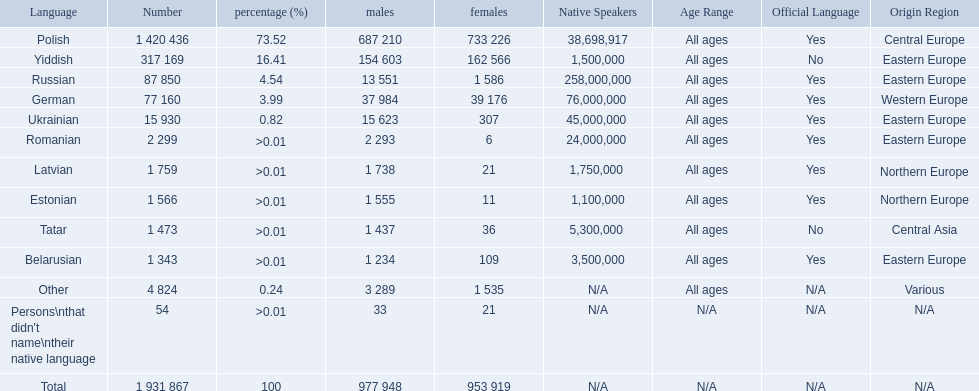What are all of the languages Polish, Yiddish, Russian, German, Ukrainian, Romanian, Latvian, Estonian, Tatar, Belarusian, Other, Persons\nthat didn't name\ntheir native language. What was the percentage of each? 73.52, 16.41, 4.54, 3.99, 0.82, >0.01, >0.01, >0.01, >0.01, >0.01, 0.24, >0.01. Which languages had a >0.01	 percentage? Romanian, Latvian, Estonian, Tatar, Belarusian. And of those, which is listed first? Romanian. 